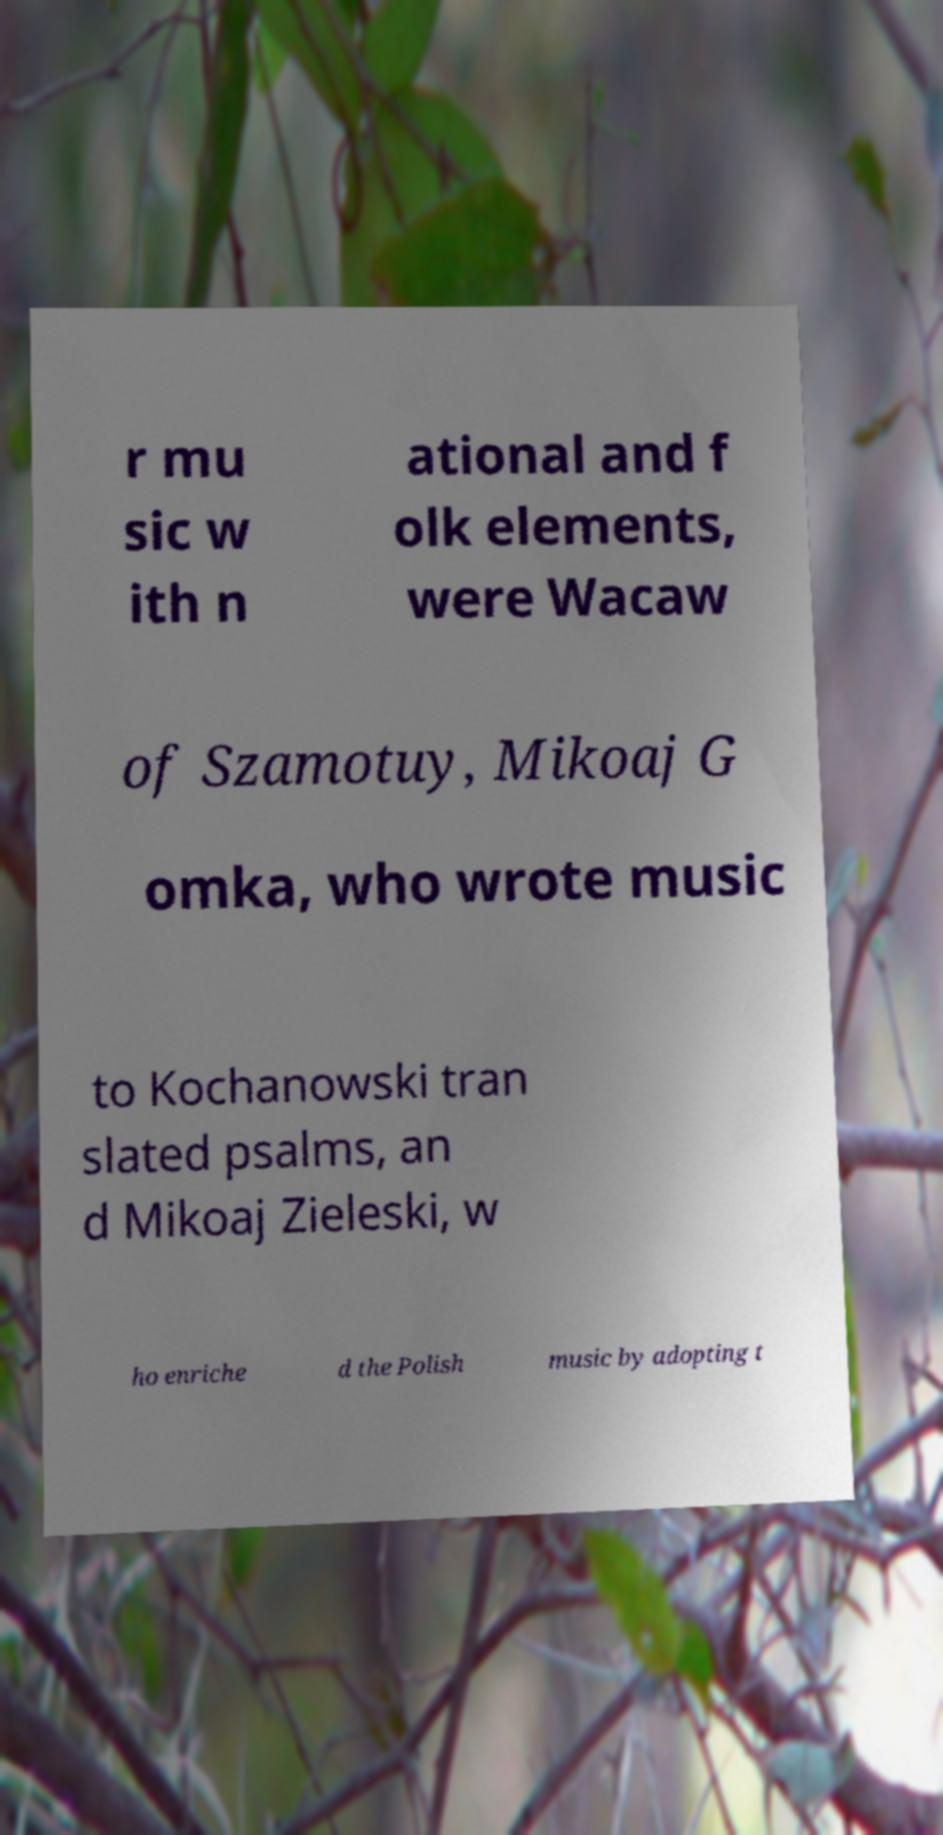Could you extract and type out the text from this image? r mu sic w ith n ational and f olk elements, were Wacaw of Szamotuy, Mikoaj G omka, who wrote music to Kochanowski tran slated psalms, an d Mikoaj Zieleski, w ho enriche d the Polish music by adopting t 